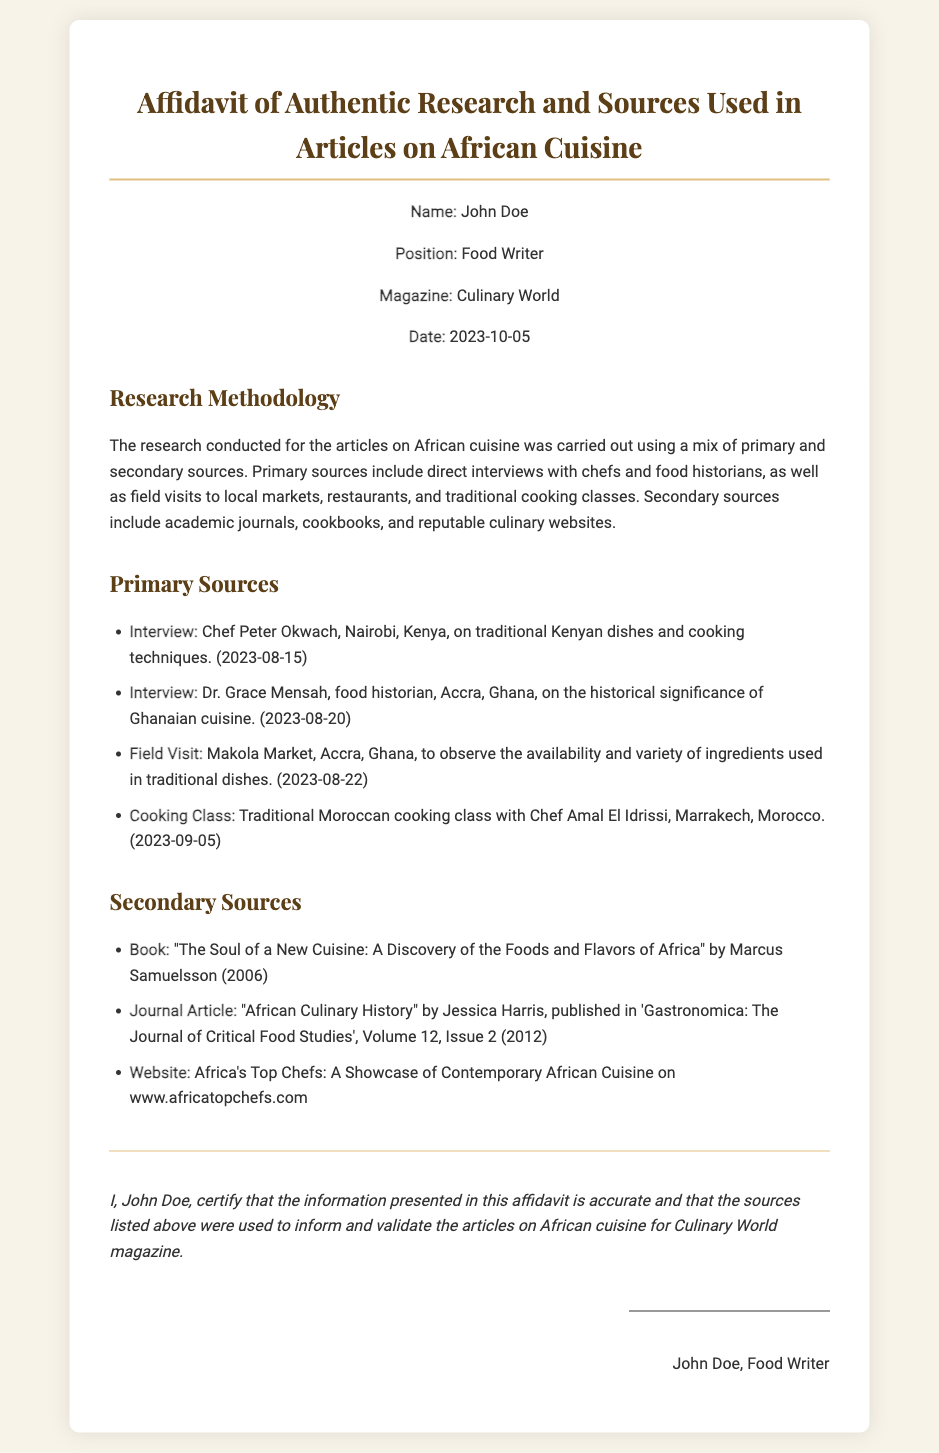What is the name of the food writer? The document states the name of the food writer clearly in the header information section.
Answer: John Doe What is the position of the individual signing the affidavit? The position is specified in the header information section of the document.
Answer: Food Writer What is the magazine associated with the affidavit? The magazine is mentioned in the header information as part of the individual's details.
Answer: Culinary World When was the affidavit signed? The date is provided in the header information at the top of the document.
Answer: 2023-10-05 Who was interviewed about traditional Kenyan dishes? The document lists various interviews conducted along with the names of individuals.
Answer: Chef Peter Okwach What type of primary source involves hands-on experience with cooking? The document categorizes the research methodology and lists types of primary sources.
Answer: Cooking Class What year was the book "The Soul of a New Cuisine" published? The document provides the publication year as part of the secondary sources listed.
Answer: 2006 Which website is mentioned in the secondary sources? The document contains a list of secondary sources, including the name of the website.
Answer: www.africatopchefs.com Who is the author of the journal article "African Culinary History"? The document identifies the author in the secondary sources section.
Answer: Jessica Harris 